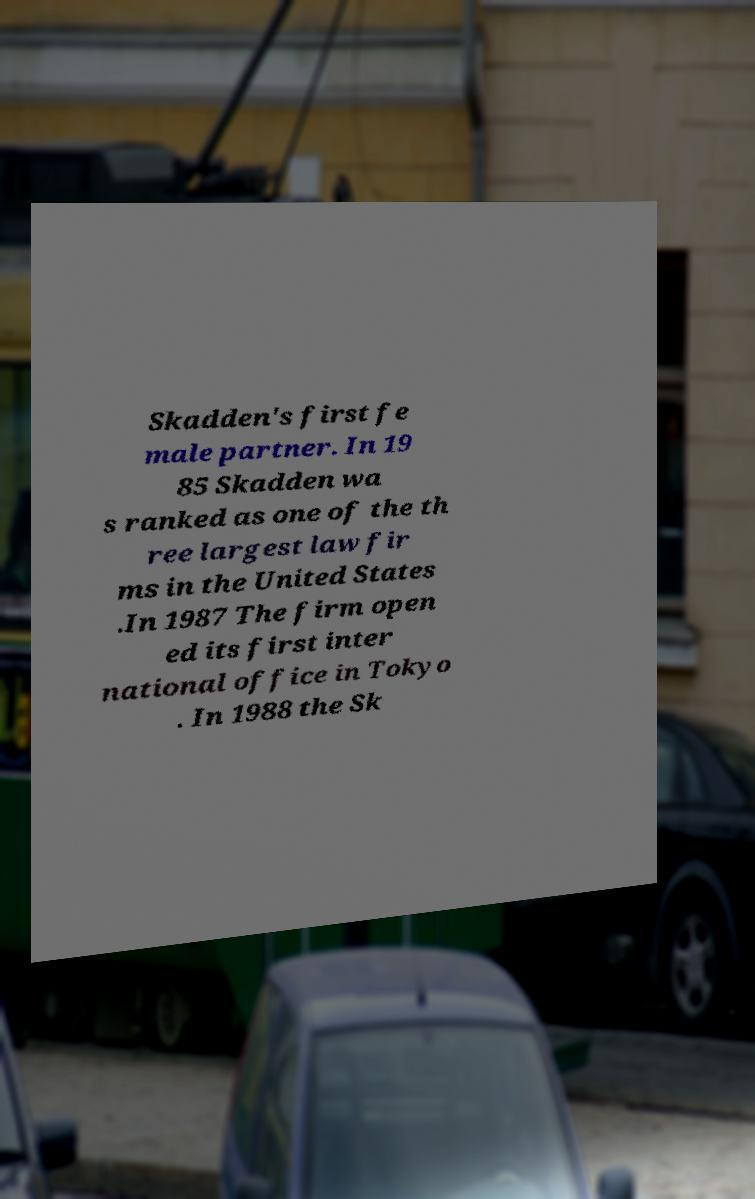Please read and relay the text visible in this image. What does it say? Skadden's first fe male partner. In 19 85 Skadden wa s ranked as one of the th ree largest law fir ms in the United States .In 1987 The firm open ed its first inter national office in Tokyo . In 1988 the Sk 